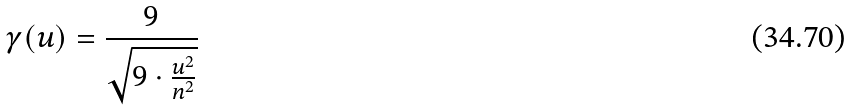<formula> <loc_0><loc_0><loc_500><loc_500>\gamma ( u ) = \frac { 9 } { \sqrt { 9 \cdot \frac { u ^ { 2 } } { n ^ { 2 } } } }</formula> 